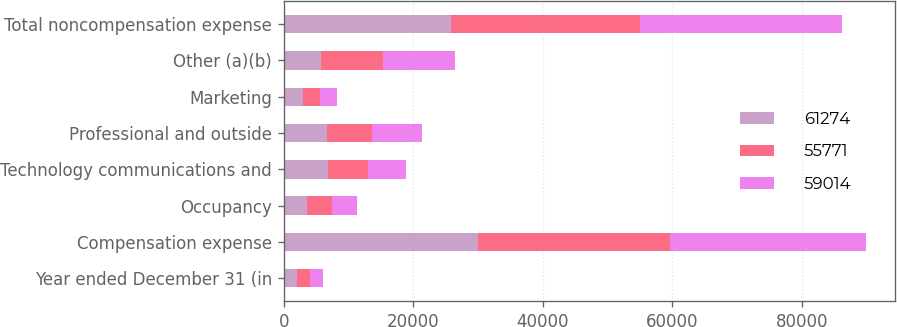Convert chart. <chart><loc_0><loc_0><loc_500><loc_500><stacked_bar_chart><ecel><fcel>Year ended December 31 (in<fcel>Compensation expense<fcel>Occupancy<fcel>Technology communications and<fcel>Professional and outside<fcel>Marketing<fcel>Other (a)(b)<fcel>Total noncompensation expense<nl><fcel>61274<fcel>2016<fcel>29979<fcel>3638<fcel>6846<fcel>6655<fcel>2897<fcel>5756<fcel>25792<nl><fcel>55771<fcel>2015<fcel>29750<fcel>3768<fcel>6193<fcel>7002<fcel>2708<fcel>9593<fcel>29264<nl><fcel>59014<fcel>2014<fcel>30160<fcel>3909<fcel>5804<fcel>7705<fcel>2550<fcel>11146<fcel>31114<nl></chart> 